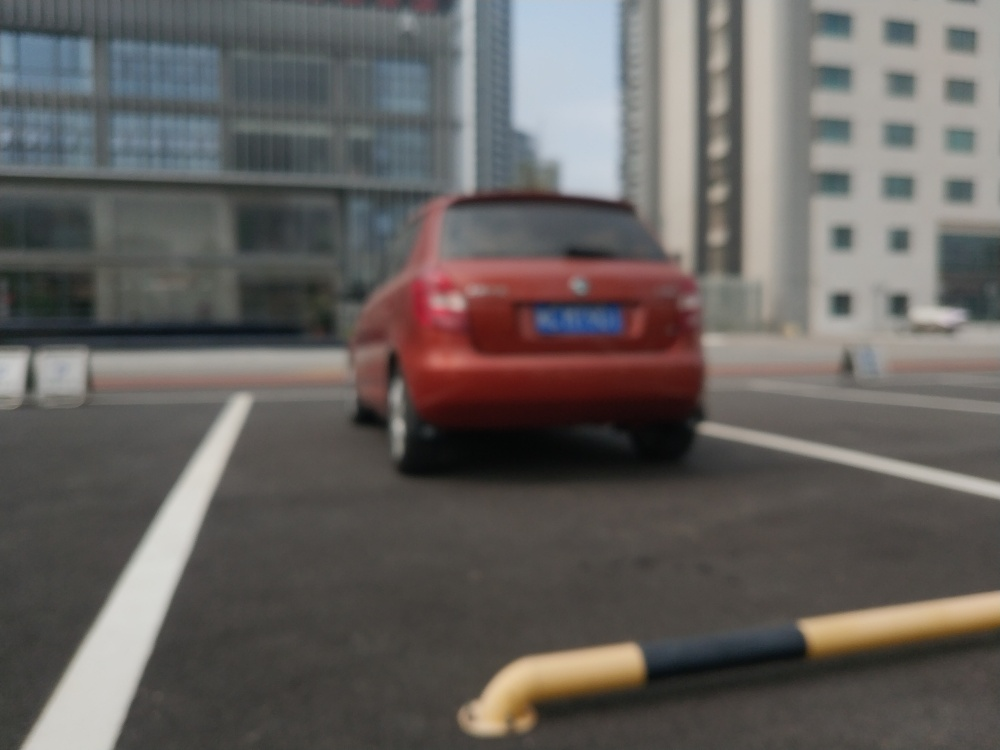What emotions does this image evoke, and how might it be used to convey a message? The blurriness of the image induces a sense of movement or haste, possibly evoking feelings of urgency or the fast pace of urban life. This photograph might be used in a narrative emphasizing the fleeting moments we experience daily or to underscore the theme of life's transience in the midst of a bustling city. 